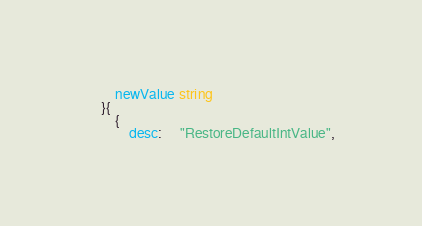Convert code to text. <code><loc_0><loc_0><loc_500><loc_500><_Go_>		newValue string
	}{
		{
			desc:     "RestoreDefaultIntValue",</code> 